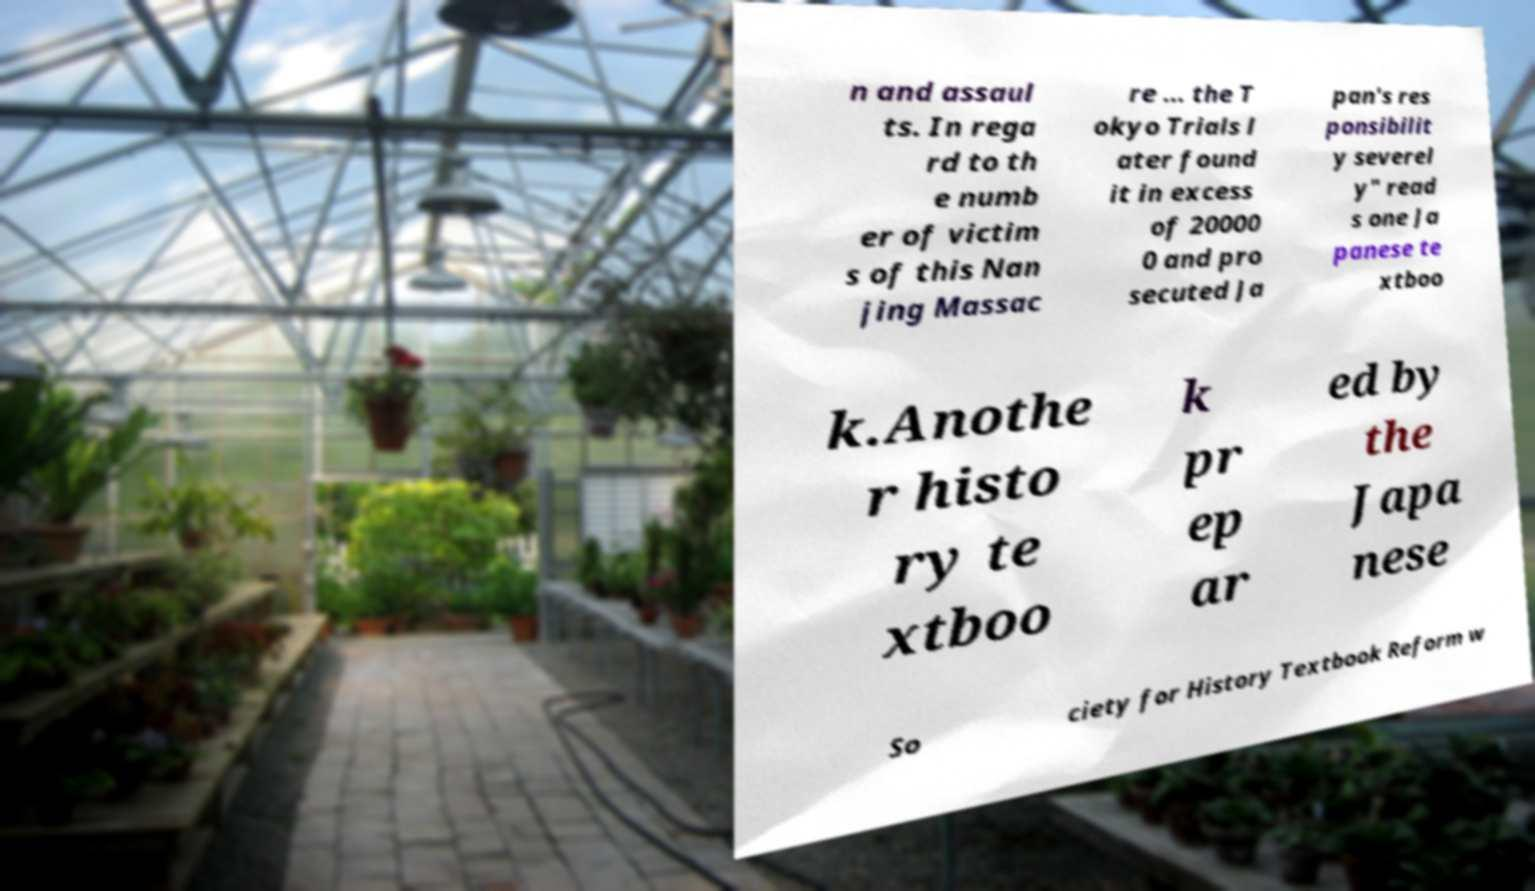Could you assist in decoding the text presented in this image and type it out clearly? n and assaul ts. In rega rd to th e numb er of victim s of this Nan jing Massac re ... the T okyo Trials l ater found it in excess of 20000 0 and pro secuted Ja pan's res ponsibilit y severel y" read s one Ja panese te xtboo k.Anothe r histo ry te xtboo k pr ep ar ed by the Japa nese So ciety for History Textbook Reform w 